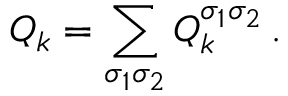<formula> <loc_0><loc_0><loc_500><loc_500>Q _ { k } = \sum _ { \sigma _ { 1 } \sigma _ { 2 } } Q _ { k } ^ { \sigma _ { 1 } \sigma _ { 2 } } \, .</formula> 